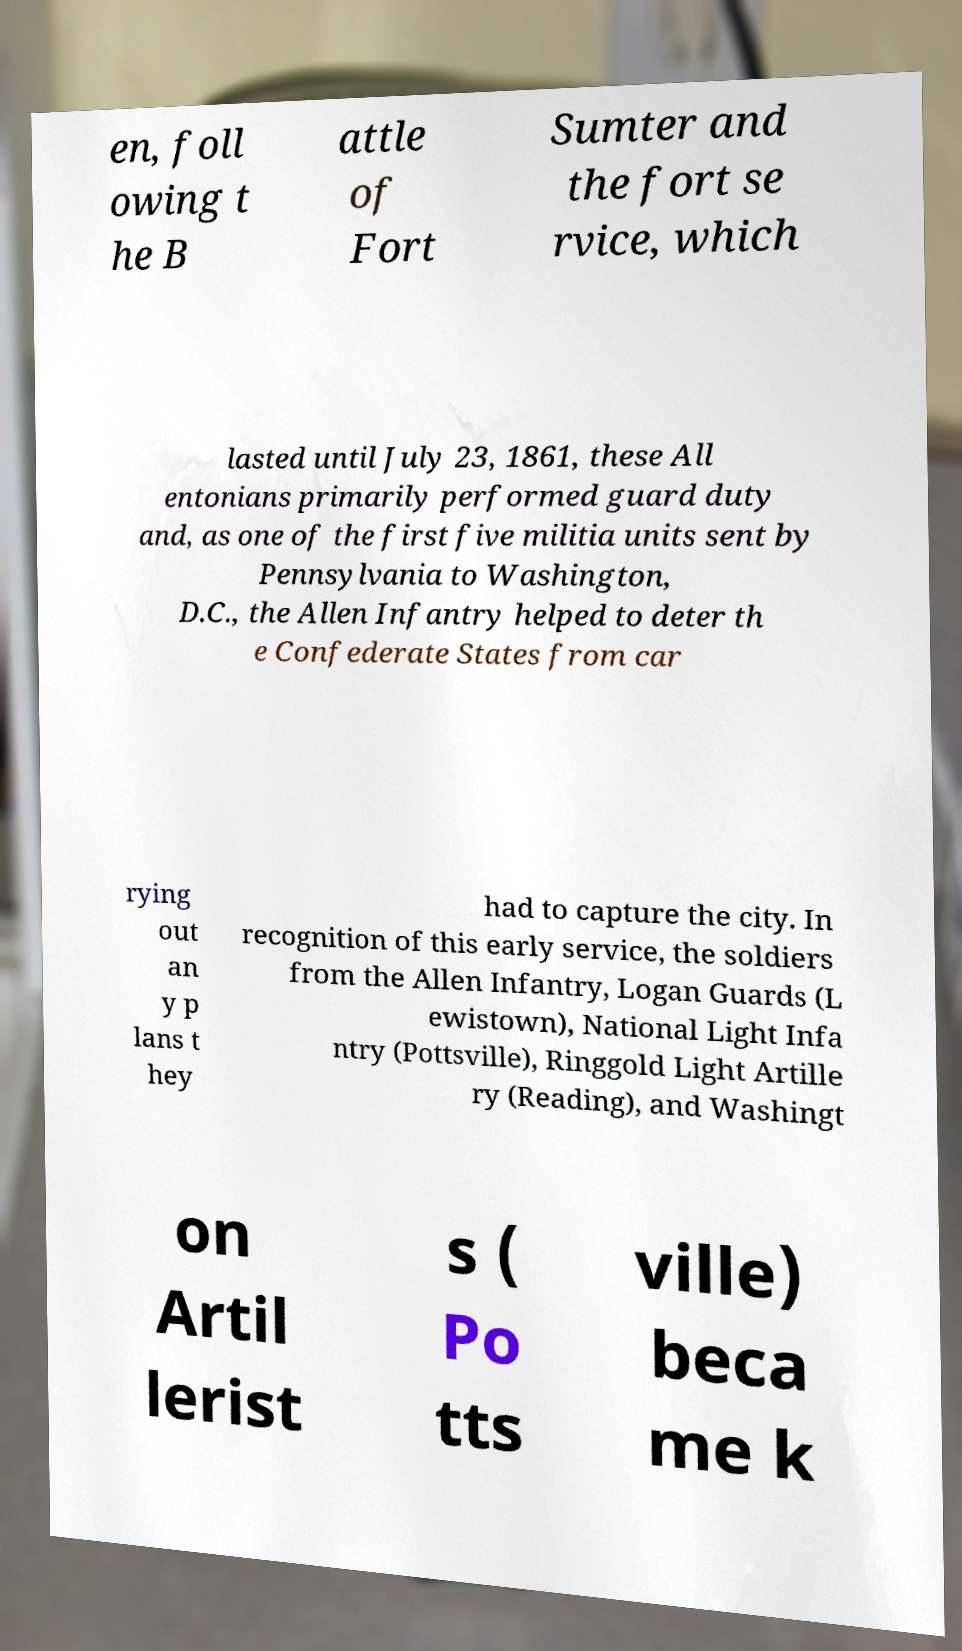For documentation purposes, I need the text within this image transcribed. Could you provide that? en, foll owing t he B attle of Fort Sumter and the fort se rvice, which lasted until July 23, 1861, these All entonians primarily performed guard duty and, as one of the first five militia units sent by Pennsylvania to Washington, D.C., the Allen Infantry helped to deter th e Confederate States from car rying out an y p lans t hey had to capture the city. In recognition of this early service, the soldiers from the Allen Infantry, Logan Guards (L ewistown), National Light Infa ntry (Pottsville), Ringgold Light Artille ry (Reading), and Washingt on Artil lerist s ( Po tts ville) beca me k 